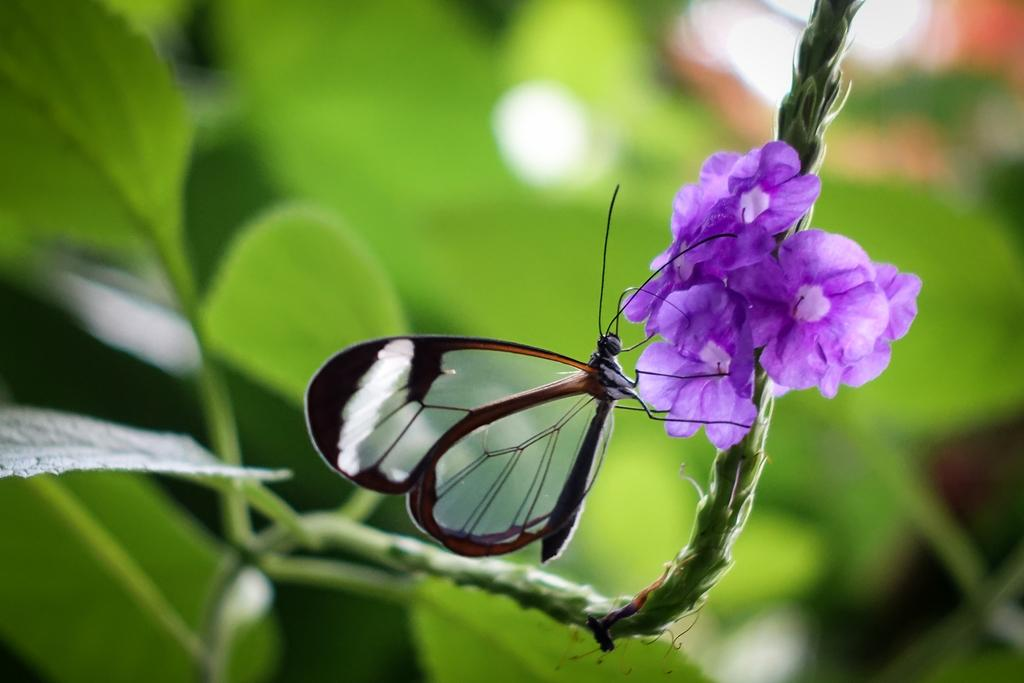What type of plant is visible in the image? There is a plant with flowers in the image. Are there any animals in the image? Yes, there is a butterfly in the image. What can be seen in the background of the image? There are other plants in the background of the image, but they are not clearly visible. What type of glove is the yak wearing in the image? There is no yak or glove present in the image. Can you provide a list of all the plants in the image? The provided facts only mention a plant with flowers and other plants in the background, so it is not possible to provide a complete list of all the plants in the image. 